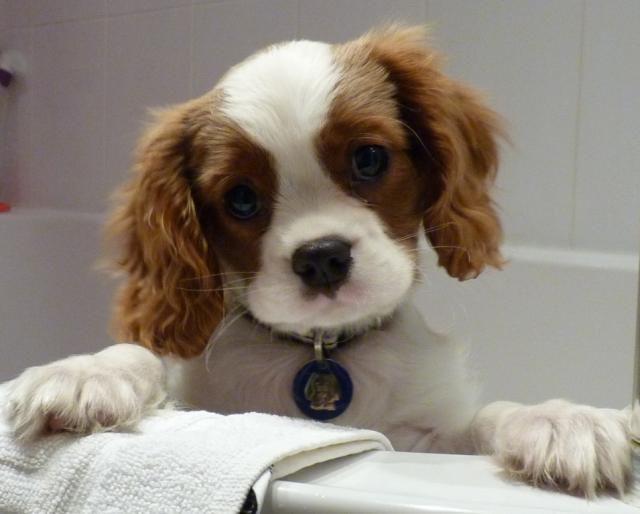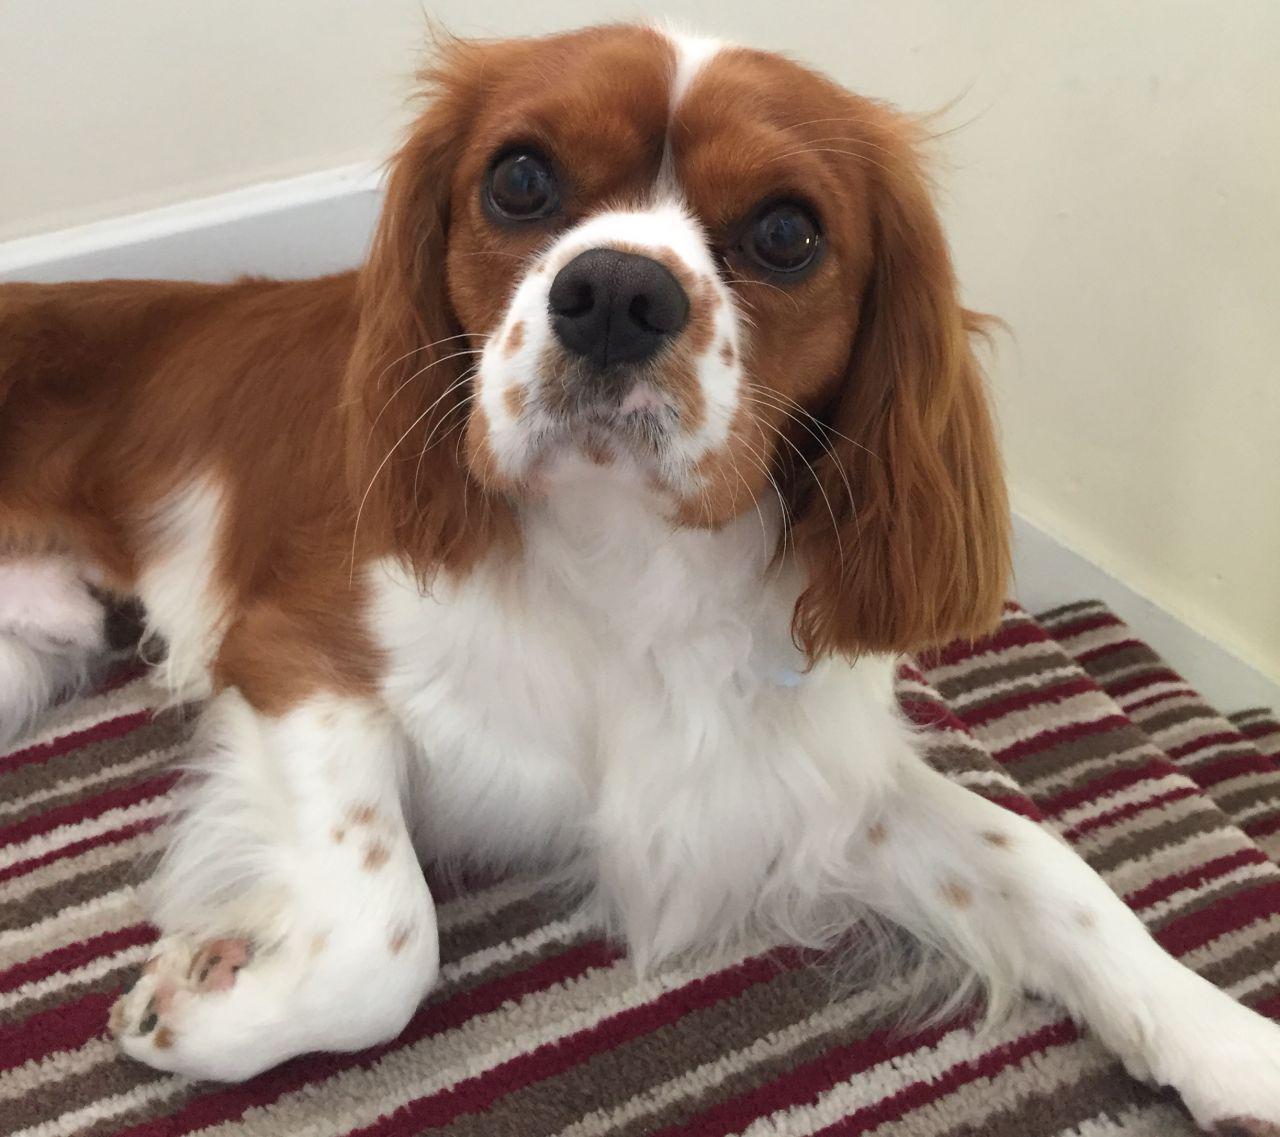The first image is the image on the left, the second image is the image on the right. Analyze the images presented: Is the assertion "All images contain only one dog." valid? Answer yes or no. Yes. 